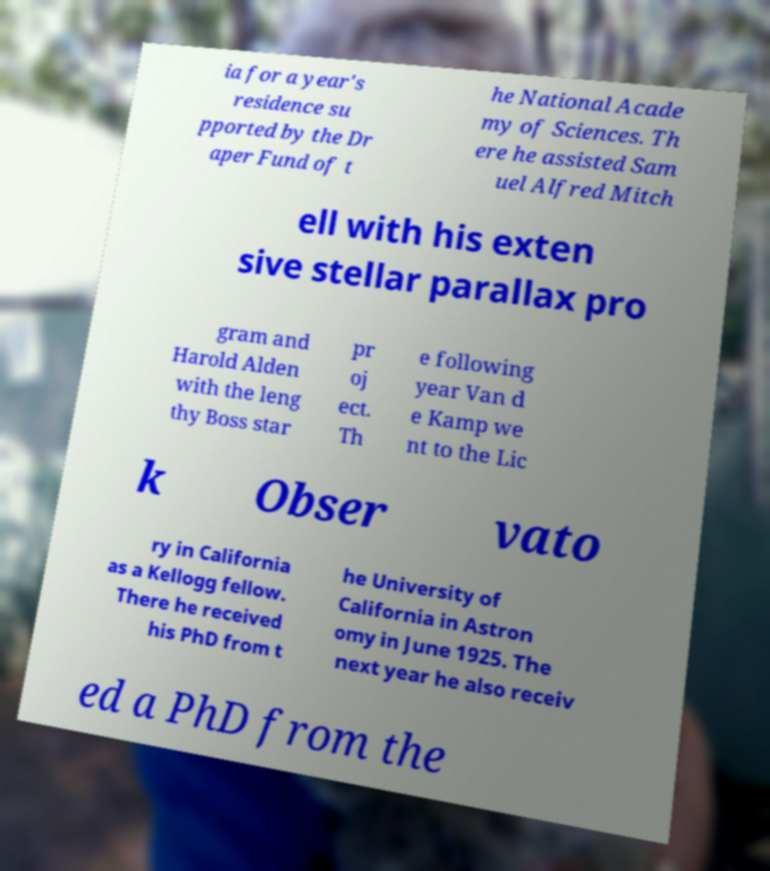Please identify and transcribe the text found in this image. ia for a year's residence su pported by the Dr aper Fund of t he National Acade my of Sciences. Th ere he assisted Sam uel Alfred Mitch ell with his exten sive stellar parallax pro gram and Harold Alden with the leng thy Boss star pr oj ect. Th e following year Van d e Kamp we nt to the Lic k Obser vato ry in California as a Kellogg fellow. There he received his PhD from t he University of California in Astron omy in June 1925. The next year he also receiv ed a PhD from the 